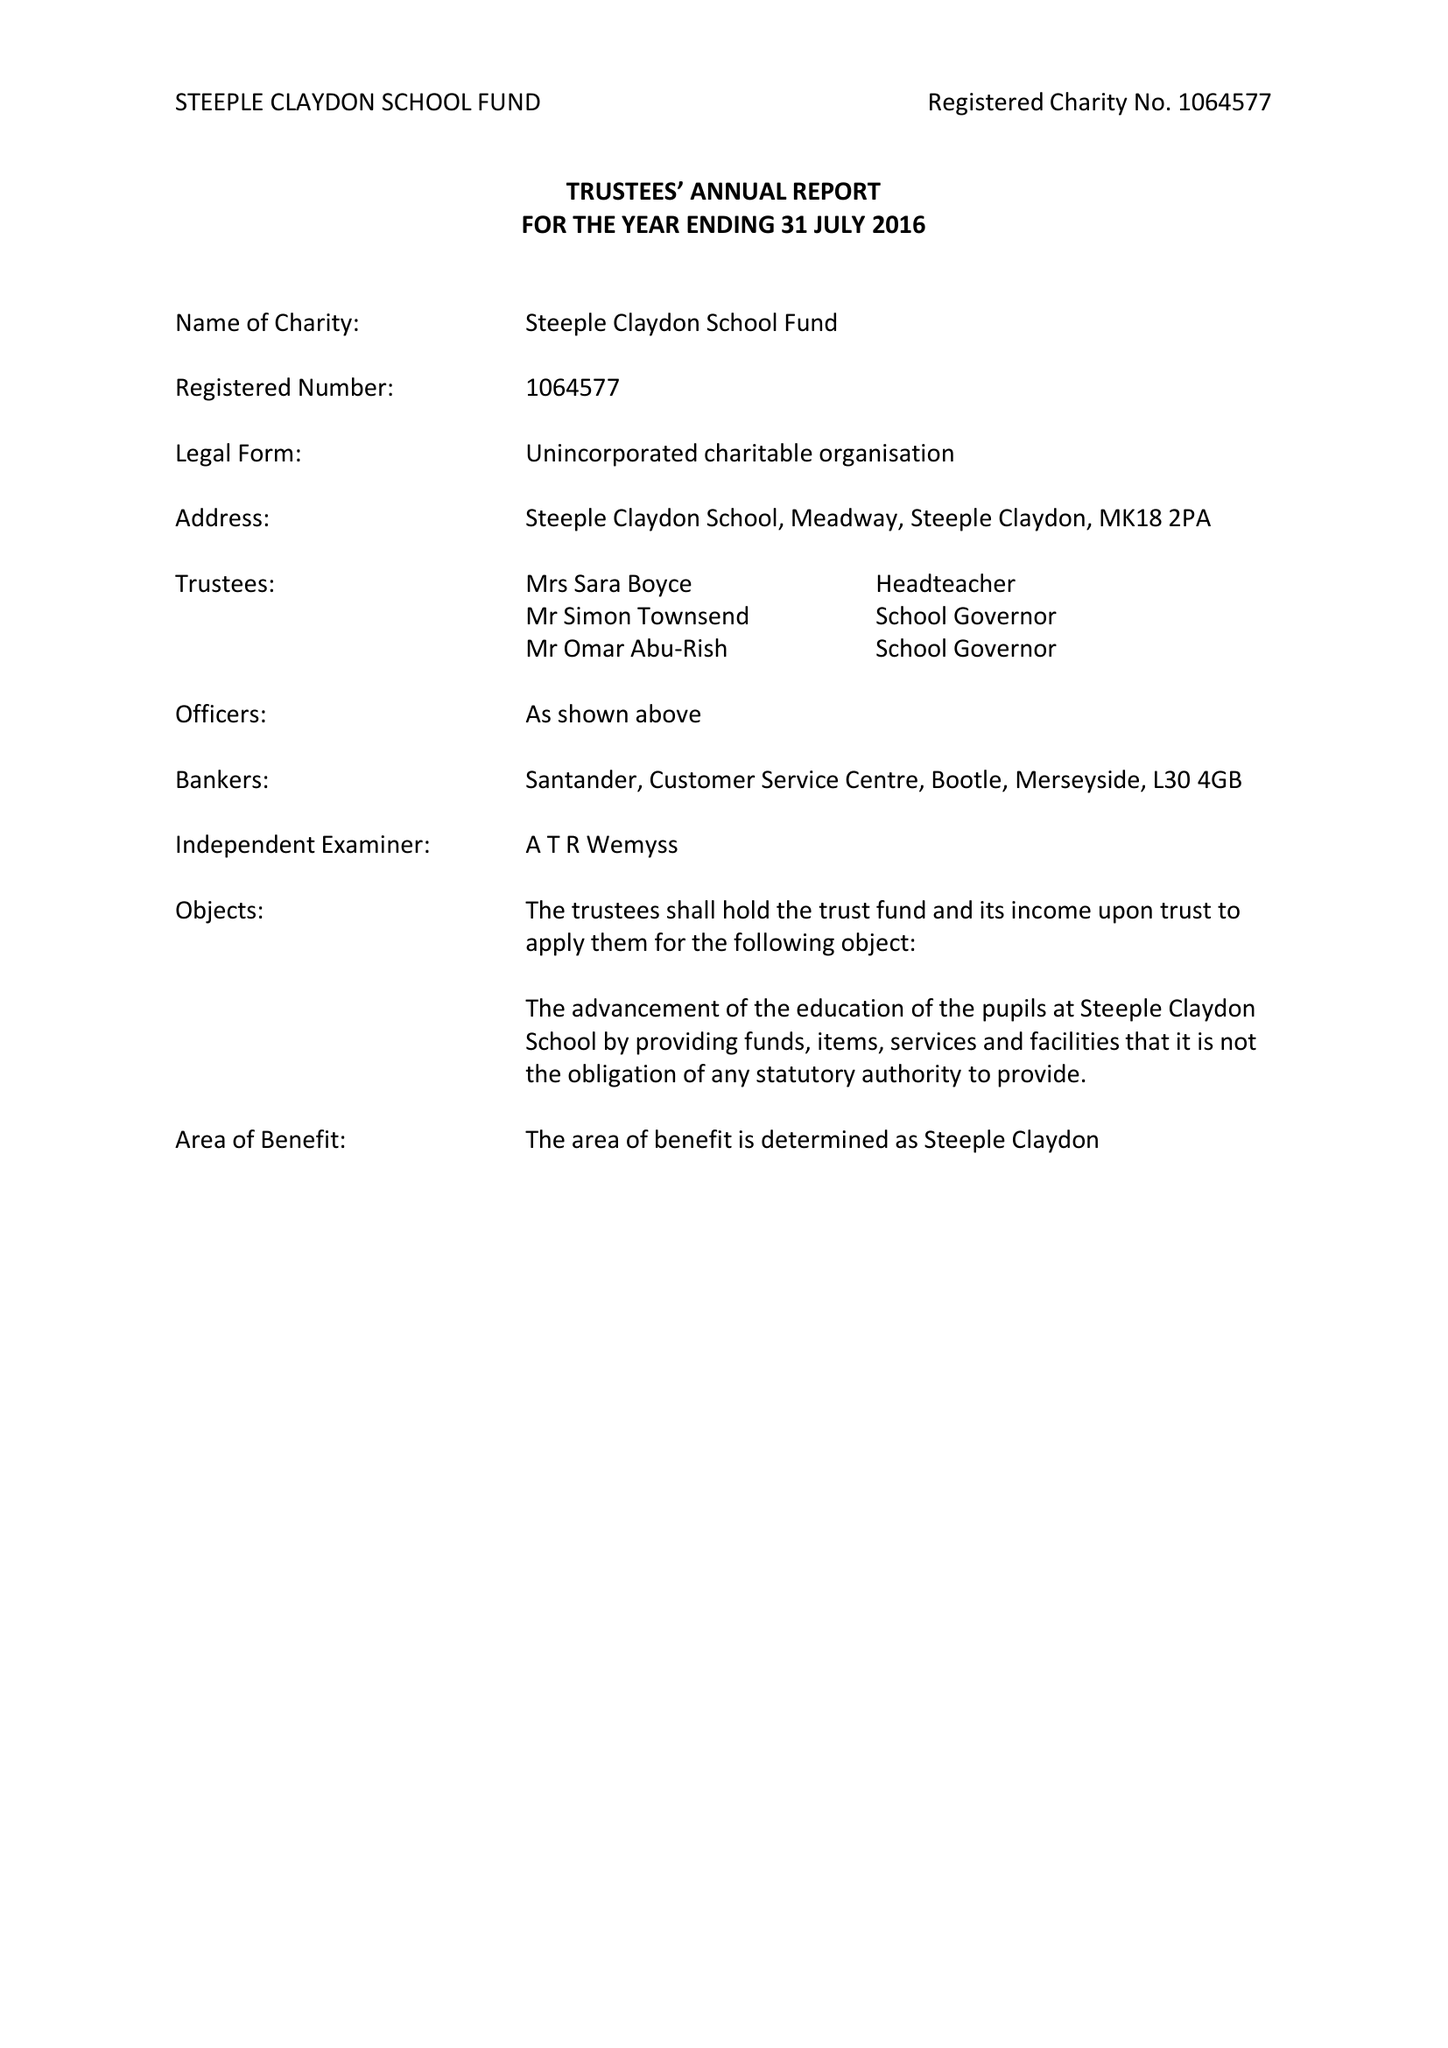What is the value for the spending_annually_in_british_pounds?
Answer the question using a single word or phrase. 48747.00 